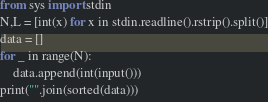<code> <loc_0><loc_0><loc_500><loc_500><_Python_>from sys import stdin
N,L = [int(x) for x in stdin.readline().rstrip().split()]
data = []
for _ in range(N):
    data.append(int(input()))
print("".join(sorted(data)))</code> 